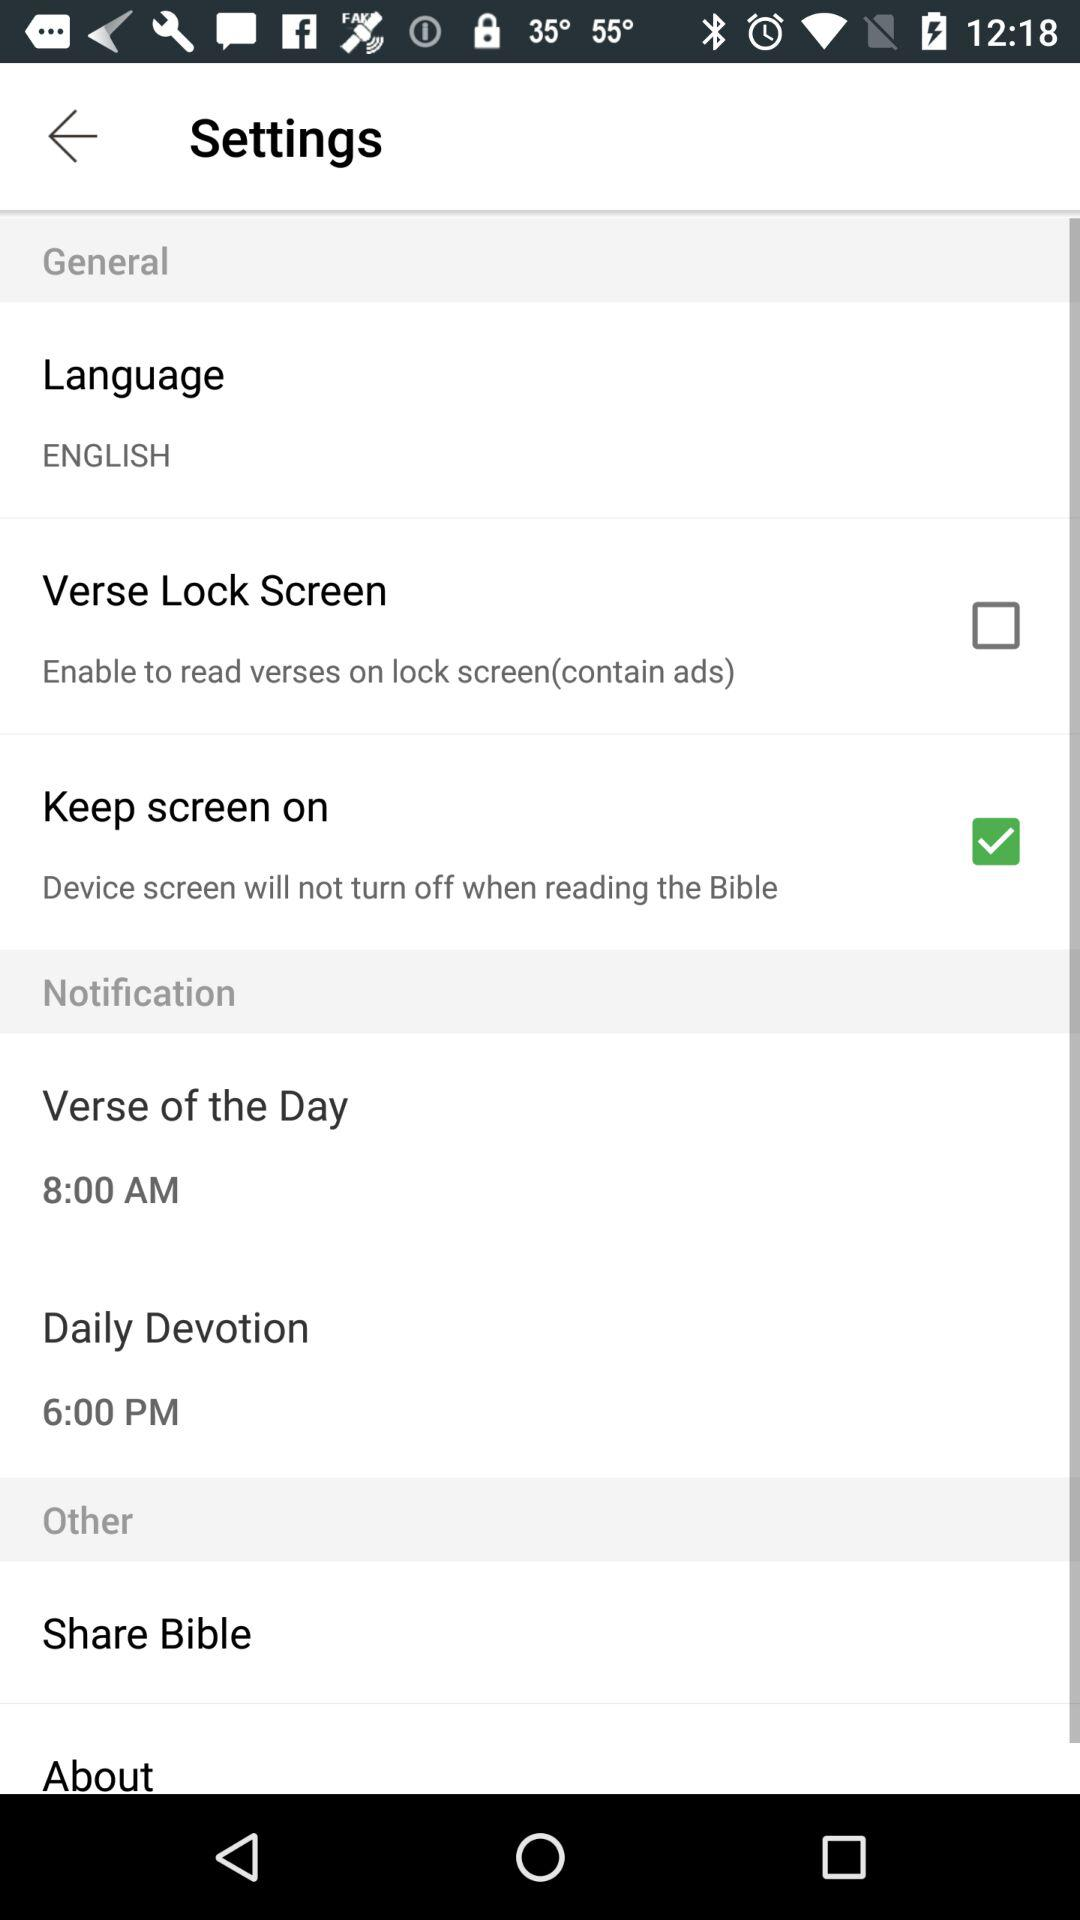Which language is set? The set language is English. 